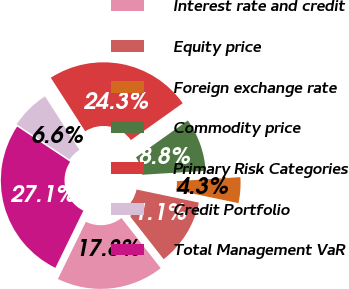Convert chart to OTSL. <chart><loc_0><loc_0><loc_500><loc_500><pie_chart><fcel>Interest rate and credit<fcel>Equity price<fcel>Foreign exchange rate<fcel>Commodity price<fcel>Primary Risk Categories<fcel>Credit Portfolio<fcel>Total Management VaR<nl><fcel>17.83%<fcel>11.13%<fcel>4.28%<fcel>8.84%<fcel>24.25%<fcel>6.56%<fcel>27.1%<nl></chart> 